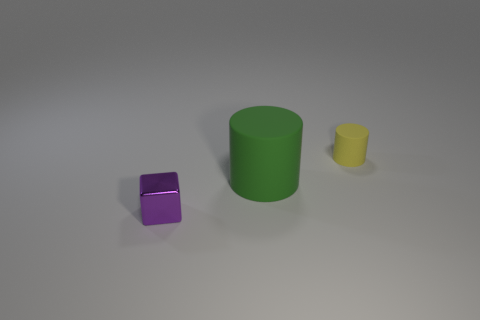Add 3 large cyan shiny blocks. How many objects exist? 6 Subtract all cylinders. How many objects are left? 1 Add 3 large green rubber objects. How many large green rubber objects are left? 4 Add 2 purple cubes. How many purple cubes exist? 3 Subtract 0 brown cubes. How many objects are left? 3 Subtract all purple cylinders. Subtract all blue cubes. How many cylinders are left? 2 Subtract all green spheres. How many yellow cylinders are left? 1 Subtract all rubber cylinders. Subtract all small shiny cylinders. How many objects are left? 1 